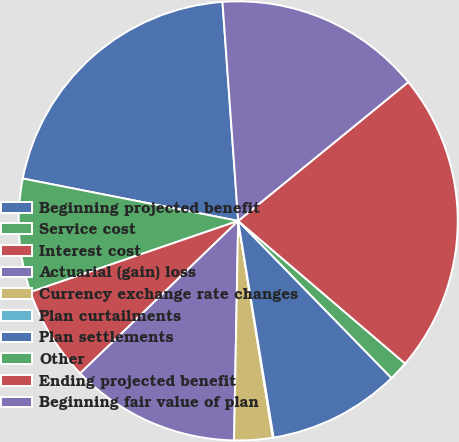Convert chart. <chart><loc_0><loc_0><loc_500><loc_500><pie_chart><fcel>Beginning projected benefit<fcel>Service cost<fcel>Interest cost<fcel>Actuarial (gain) loss<fcel>Currency exchange rate changes<fcel>Plan curtailments<fcel>Plan settlements<fcel>Other<fcel>Ending projected benefit<fcel>Beginning fair value of plan<nl><fcel>20.76%<fcel>8.34%<fcel>6.96%<fcel>12.48%<fcel>2.82%<fcel>0.06%<fcel>9.72%<fcel>1.44%<fcel>22.14%<fcel>15.24%<nl></chart> 